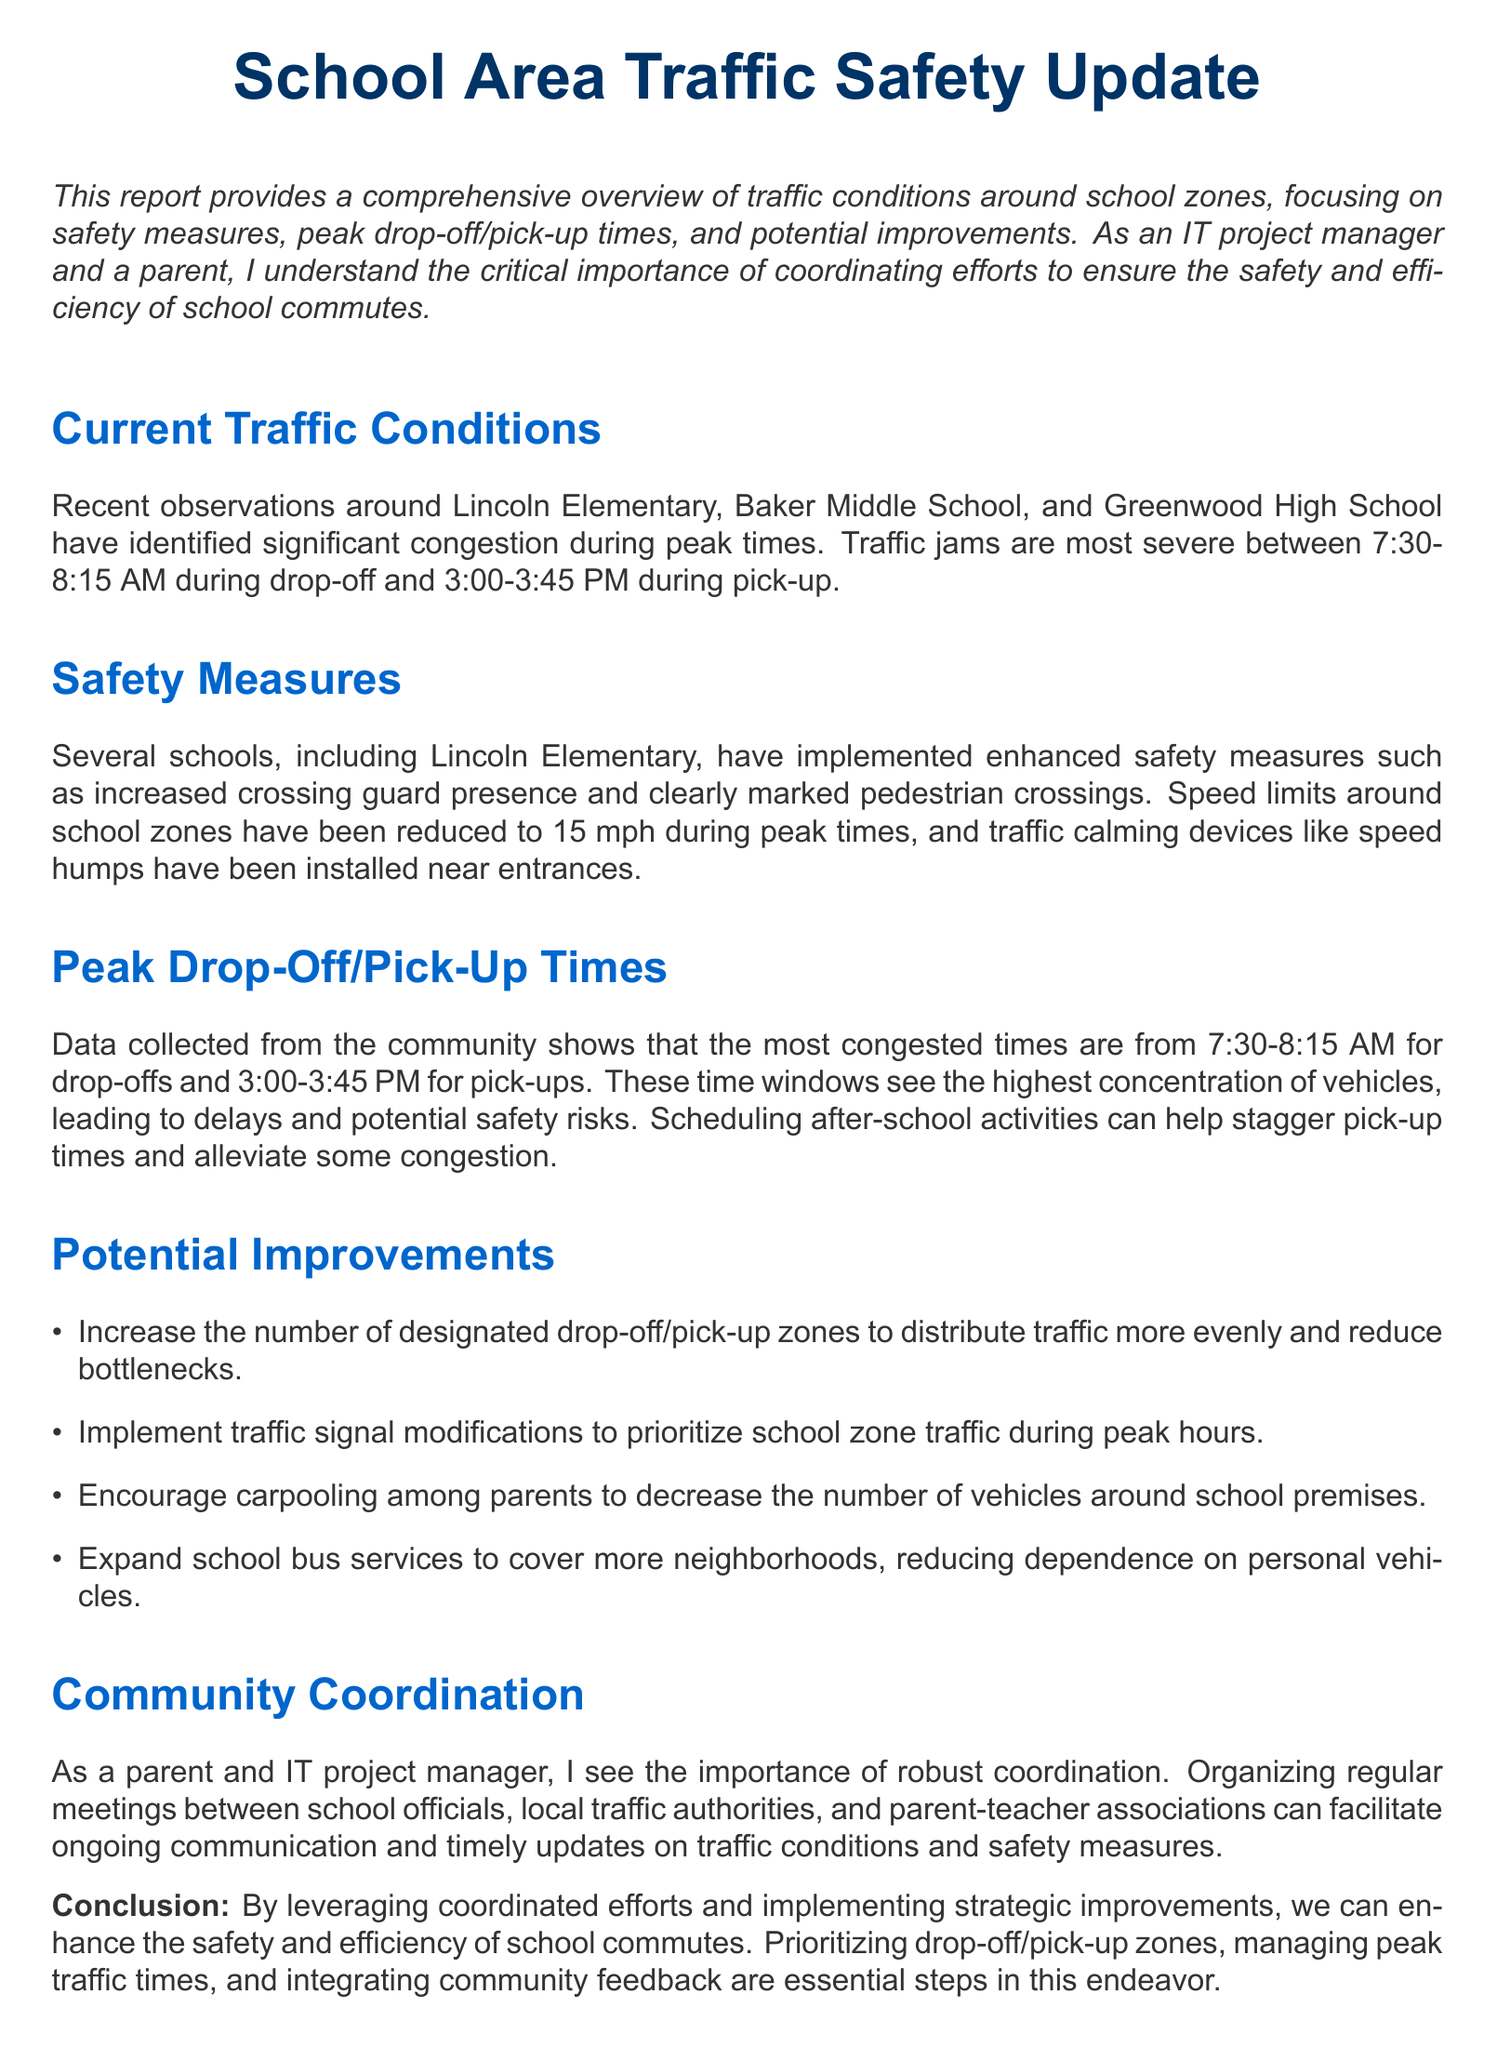What are the names of the schools mentioned in the report? The report mentions Lincoln Elementary, Baker Middle School, and Greenwood High School as the key schools with traffic concerns.
Answer: Lincoln Elementary, Baker Middle School, Greenwood High School What is the speed limit around school zones during peak times? The document specifies that the speed limit around school zones has been reduced to 15 mph during peak times to enhance safety.
Answer: 15 mph What are the peak drop-off times mentioned in the report? The report identifies the peak drop-off times as between 7:30 AM and 8:15 AM, indicating when congestion is highest.
Answer: 7:30-8:15 AM What type of safety measures have been implemented at Lincoln Elementary? The report states that Lincoln Elementary has increased crossing guard presence and installed clearly marked pedestrian crossings as part of their safety measures.
Answer: Increased crossing guard presence, clearly marked pedestrian crossings How can after-school activities help with congestion? The report implies that scheduling after-school activities can help stagger pick-up times, thereby reducing congestion during peak pick-up times.
Answer: Stagger pick-up times What is one potential improvement suggested in the report? The document mentions increasing the number of designated drop-off/pick-up zones as one of the suggested improvements to mitigate traffic issues.
Answer: Increase designated drop-off/pick-up zones What is the role of community coordination according to the report? The report highlights that community coordination involves organizing regular meetings between stakeholders like school officials and parents to enhance communication about traffic safety.
Answer: Organizing regular meetings What is the purpose of the report? The purpose outlined in the document emphasizes providing a comprehensive overview of traffic conditions around school zones, focusing on safety measures and improvements.
Answer: Overview of traffic conditions around school zones 